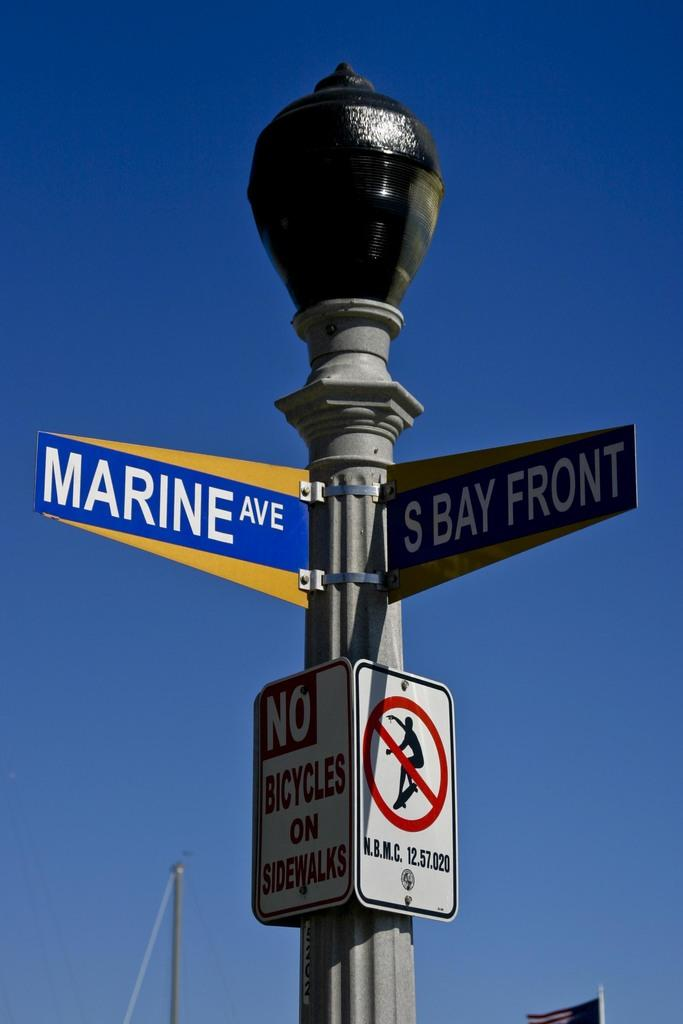<image>
Relay a brief, clear account of the picture shown. a sign that says marine ave on it 